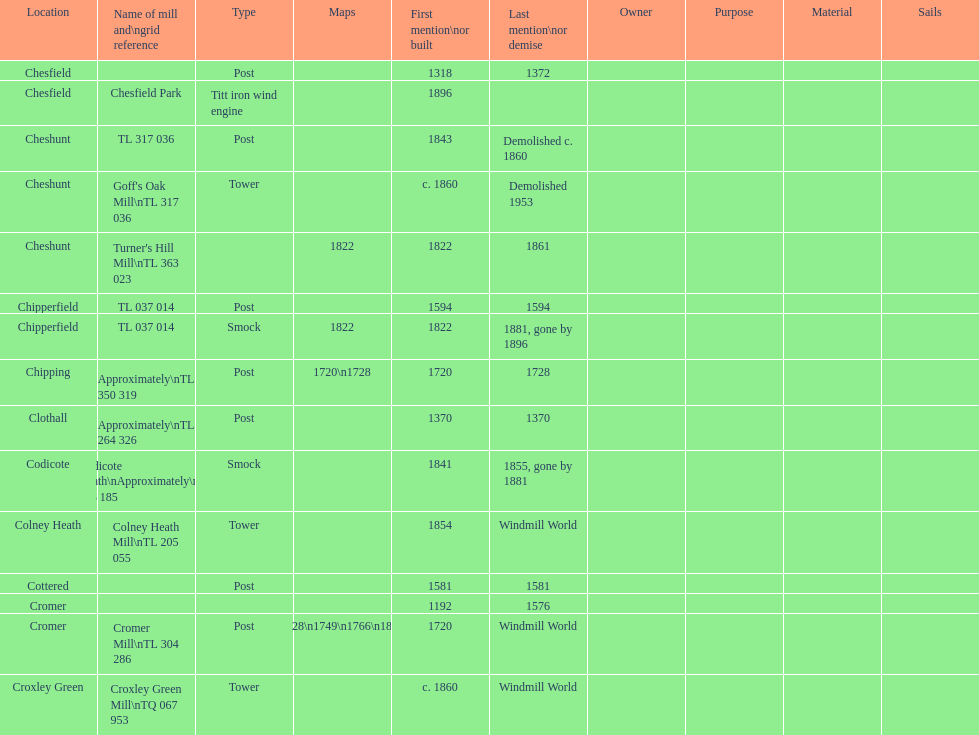What location has the most maps? Cromer. 